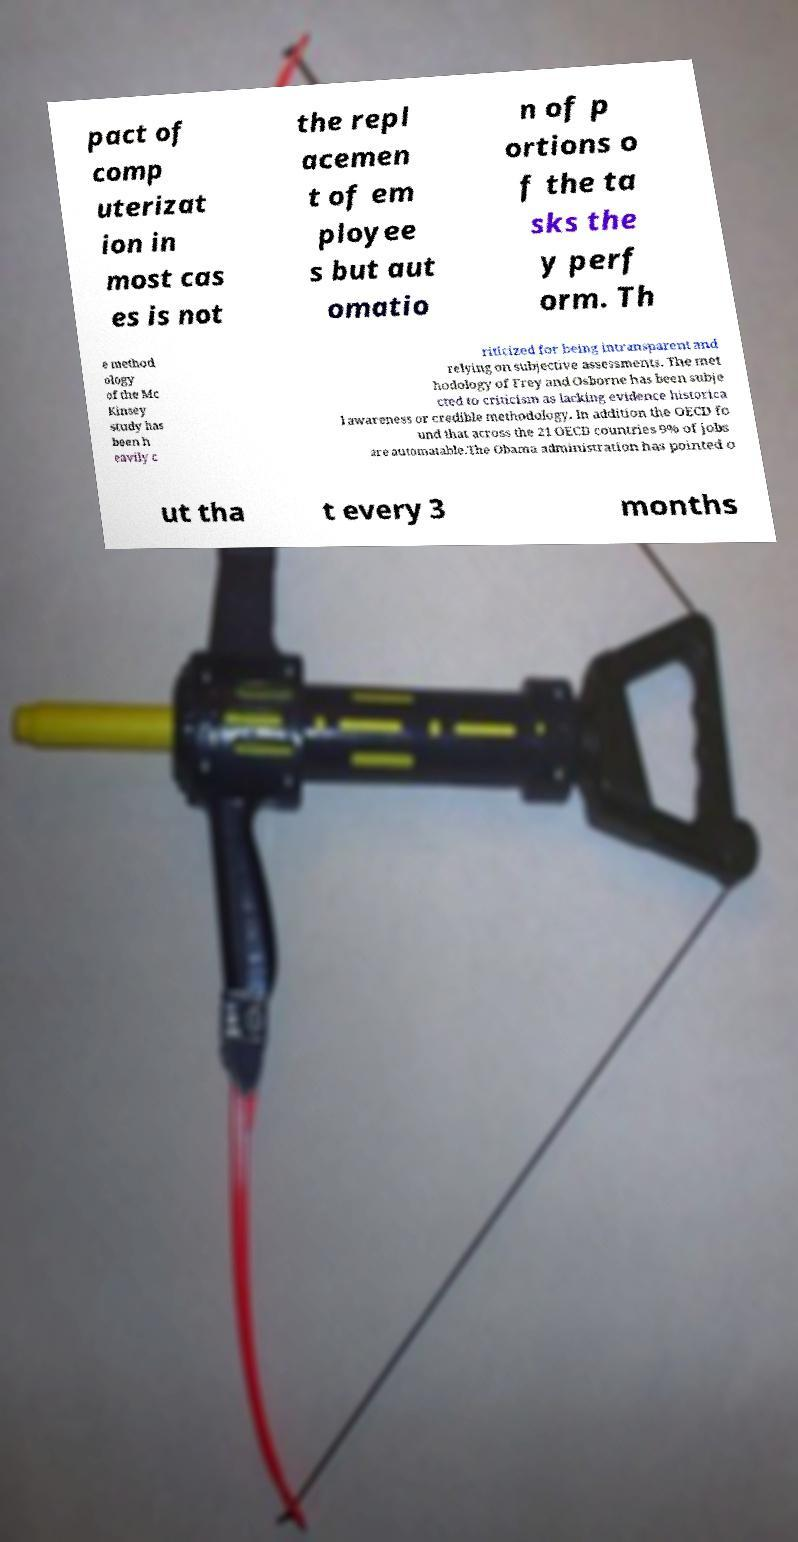Please read and relay the text visible in this image. What does it say? pact of comp uterizat ion in most cas es is not the repl acemen t of em ployee s but aut omatio n of p ortions o f the ta sks the y perf orm. Th e method ology of the Mc Kinsey study has been h eavily c riticized for being intransparent and relying on subjective assessments. The met hodology of Frey and Osborne has been subje cted to criticism as lacking evidence historica l awareness or credible methodology. In addition the OECD fo und that across the 21 OECD countries 9% of jobs are automatable.The Obama administration has pointed o ut tha t every 3 months 